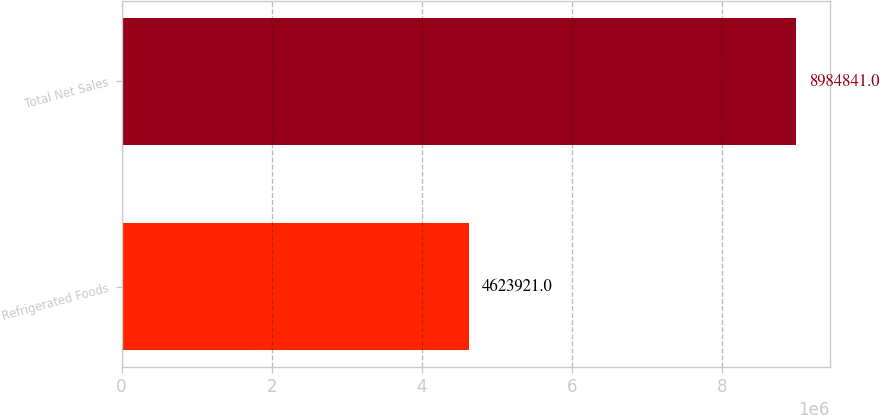<chart> <loc_0><loc_0><loc_500><loc_500><bar_chart><fcel>Refrigerated Foods<fcel>Total Net Sales<nl><fcel>4.62392e+06<fcel>8.98484e+06<nl></chart> 